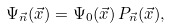<formula> <loc_0><loc_0><loc_500><loc_500>\Psi _ { \vec { n } } ( \vec { x } ) = \Psi _ { 0 } ( \vec { x } ) \, P _ { \vec { n } } ( \vec { x } ) ,</formula> 